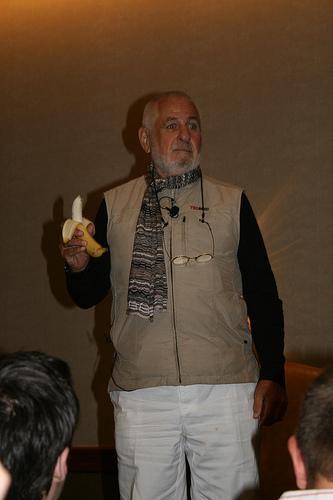How many people are shown in total?
Give a very brief answer. 3. How many people are facing the camera?
Give a very brief answer. 1. 